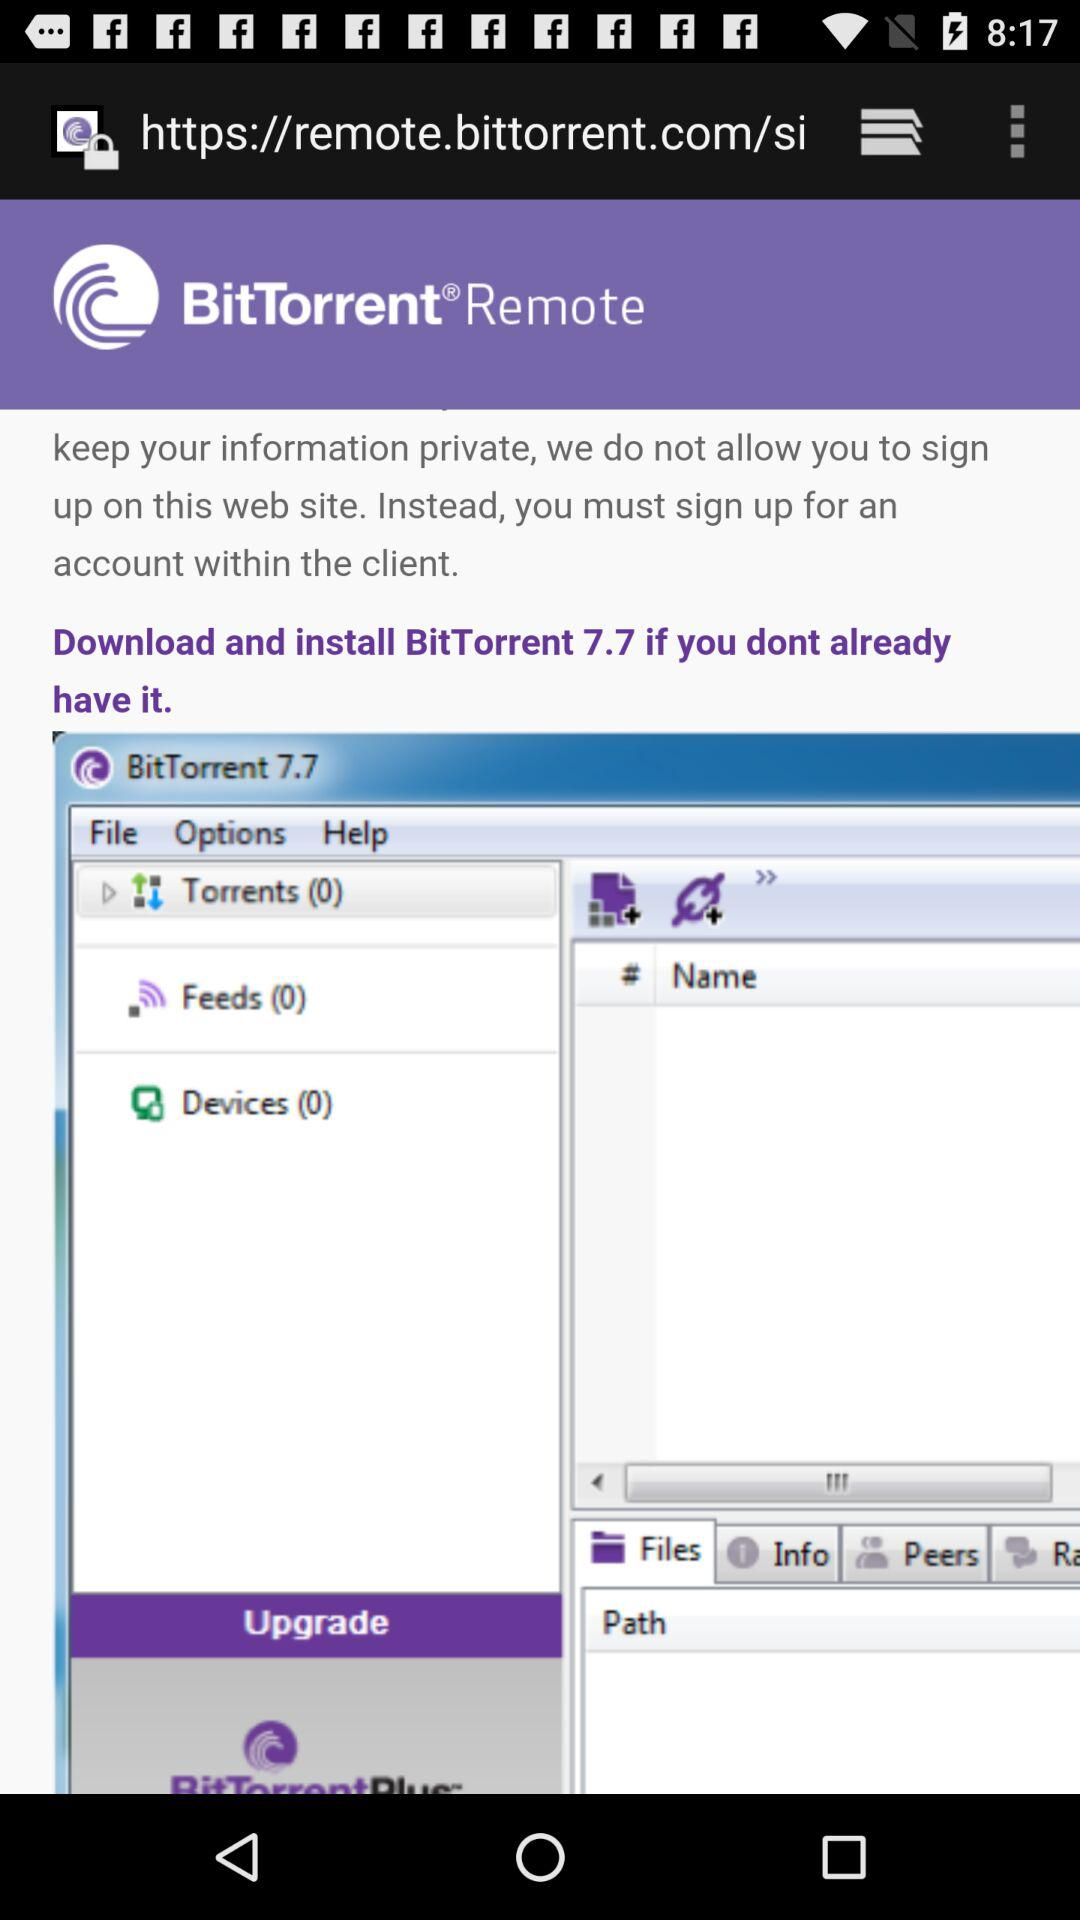What is the version of BitTorrent? The version is 7.7. 